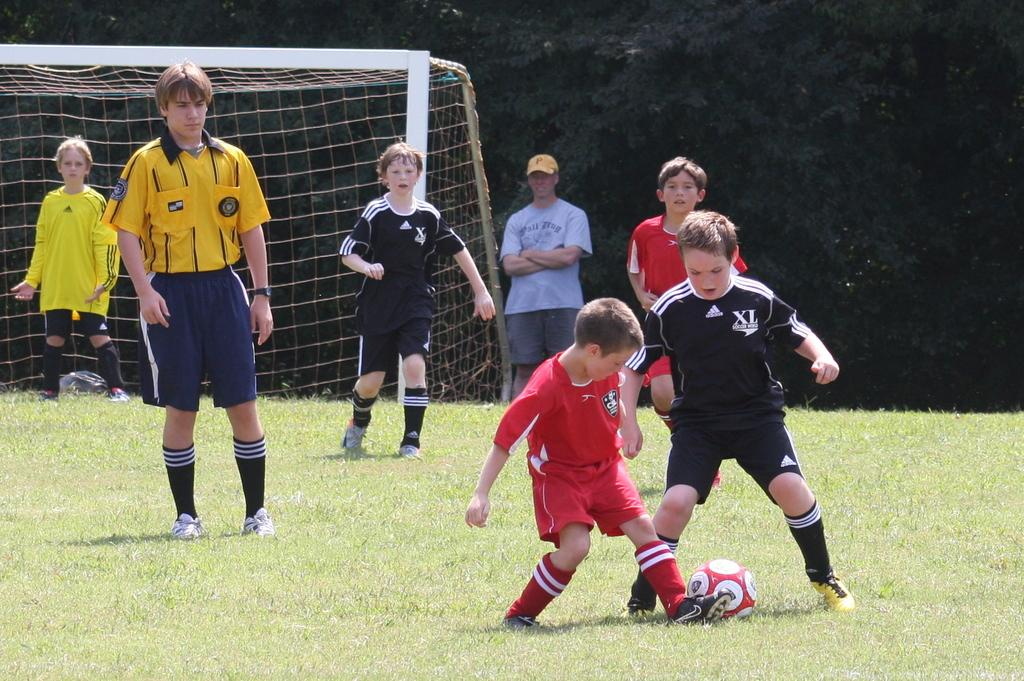What activity is the group of persons in the image engaged in? The group of persons is playing football. Where is the football game taking place? The football game is taking place on a ground. What can be seen in the background of the image? There are trees and a net in the background of the image. What type of rod is being used by the players to hit the football in the image? There is no rod present in the image; the players are using their feet to play football. 